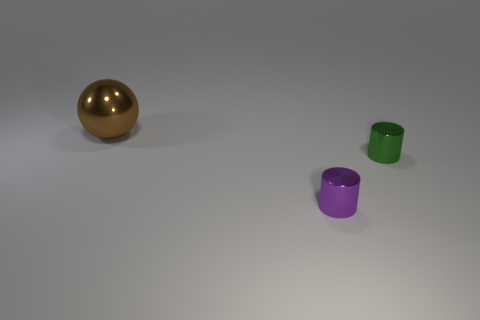Are there any small yellow objects that have the same material as the green cylinder? no 